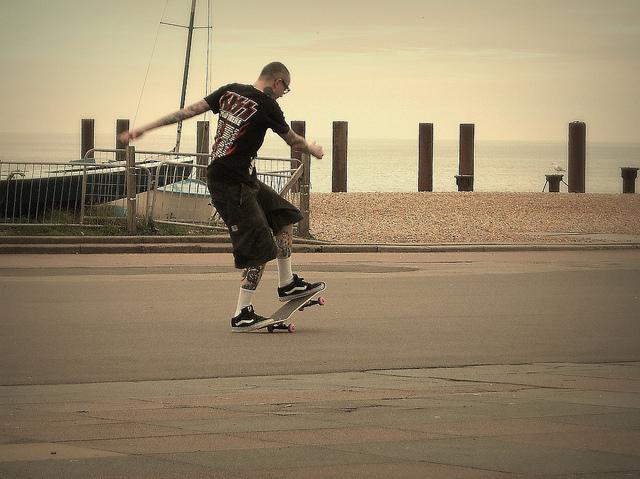What band name is on the man's shirt?
Keep it brief. Kiss. Which foot is pushing off?
Be succinct. Right. Where is a bus stop?
Keep it brief. Nowhere. Does the ground look wet?
Answer briefly. No. What brand of shoes are those?
Be succinct. Nike. Do you like the boy's shorts?
Short answer required. Yes. Is the ground wet?
Be succinct. No. What is he skateboarding on?
Quick response, please. Street. What color is the picture?
Short answer required. Sepia. Which sport is this?
Give a very brief answer. Skateboarding. How many wheels are touching the ground?
Short answer required. 2. Is this summer time?
Concise answer only. Yes. Is he smoking?
Concise answer only. No. Is he wearing socks?
Keep it brief. Yes. Was this taken in a large city?
Concise answer only. No. What are the tall pillars in the background called?
Give a very brief answer. Posts. 